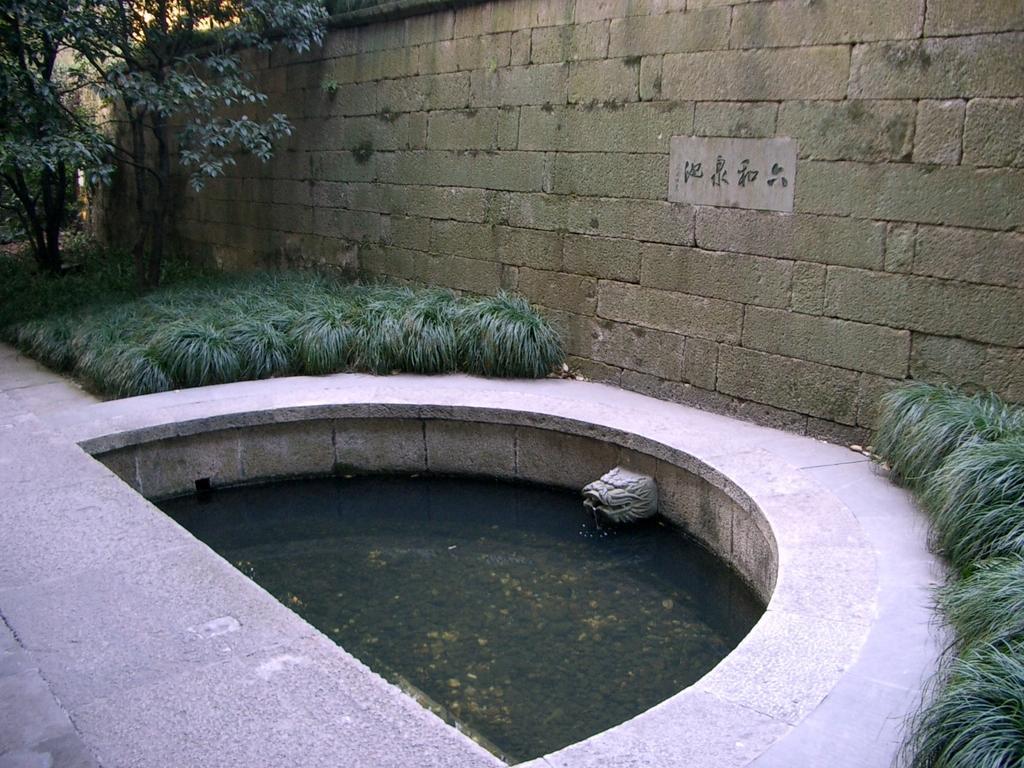Describe this image in one or two sentences. This picture is clicked outside. In the center we can see an object seems to be the and we can see the water and we can see the green grass, trees. In the background we can see the stone wall. 